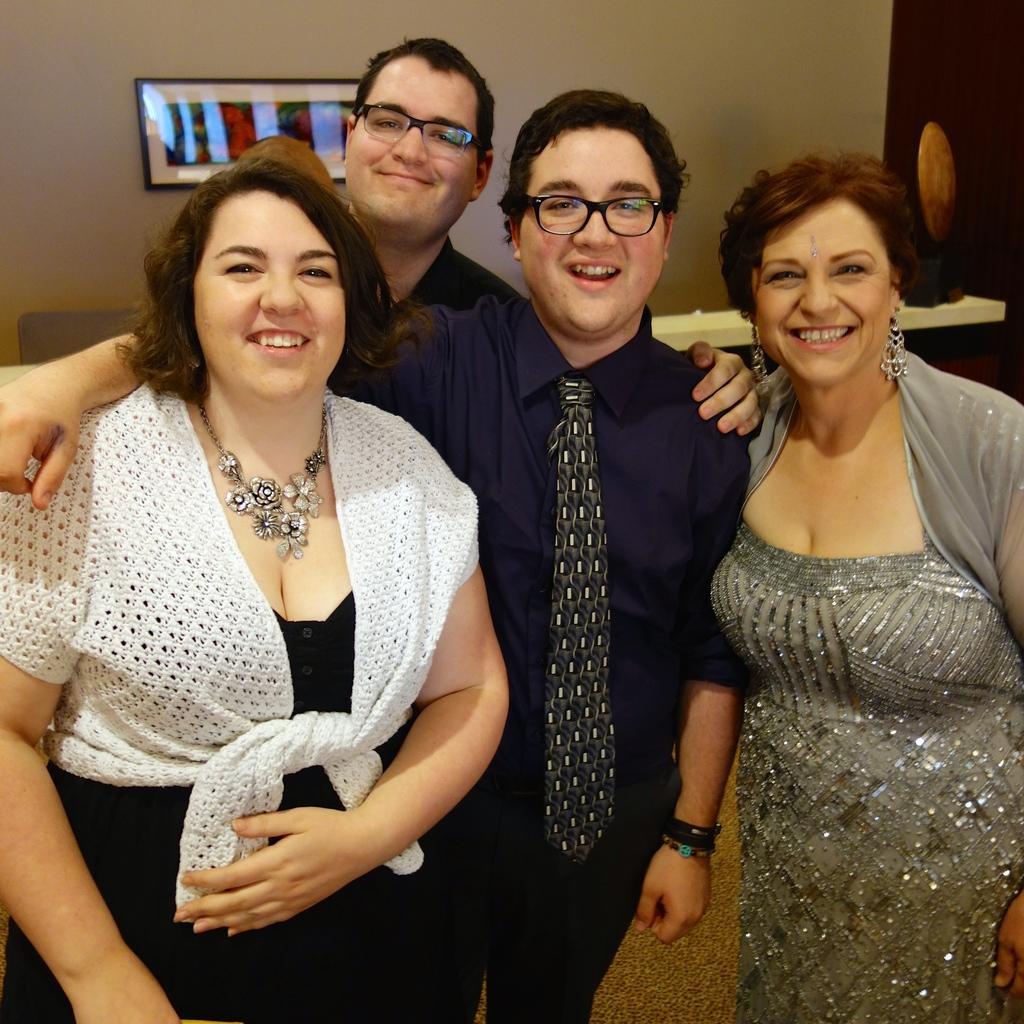Describe this image in one or two sentences. In this picture there are persons standing in the center and smiling. In the background there is frame on the wall and the wall is white in colour. 